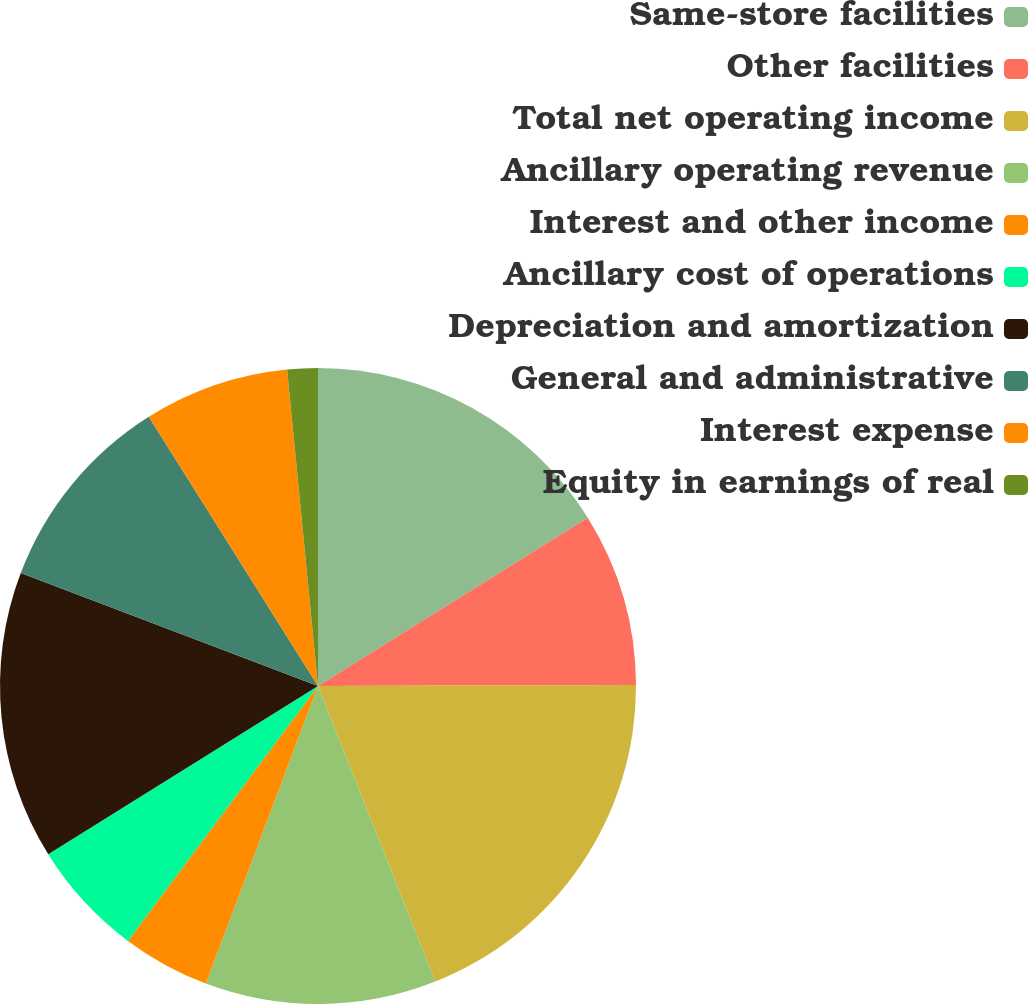Convert chart. <chart><loc_0><loc_0><loc_500><loc_500><pie_chart><fcel>Same-store facilities<fcel>Other facilities<fcel>Total net operating income<fcel>Ancillary operating revenue<fcel>Interest and other income<fcel>Ancillary cost of operations<fcel>Depreciation and amortization<fcel>General and administrative<fcel>Interest expense<fcel>Equity in earnings of real<nl><fcel>16.12%<fcel>8.83%<fcel>19.04%<fcel>11.75%<fcel>4.46%<fcel>5.92%<fcel>14.66%<fcel>10.29%<fcel>7.38%<fcel>1.55%<nl></chart> 